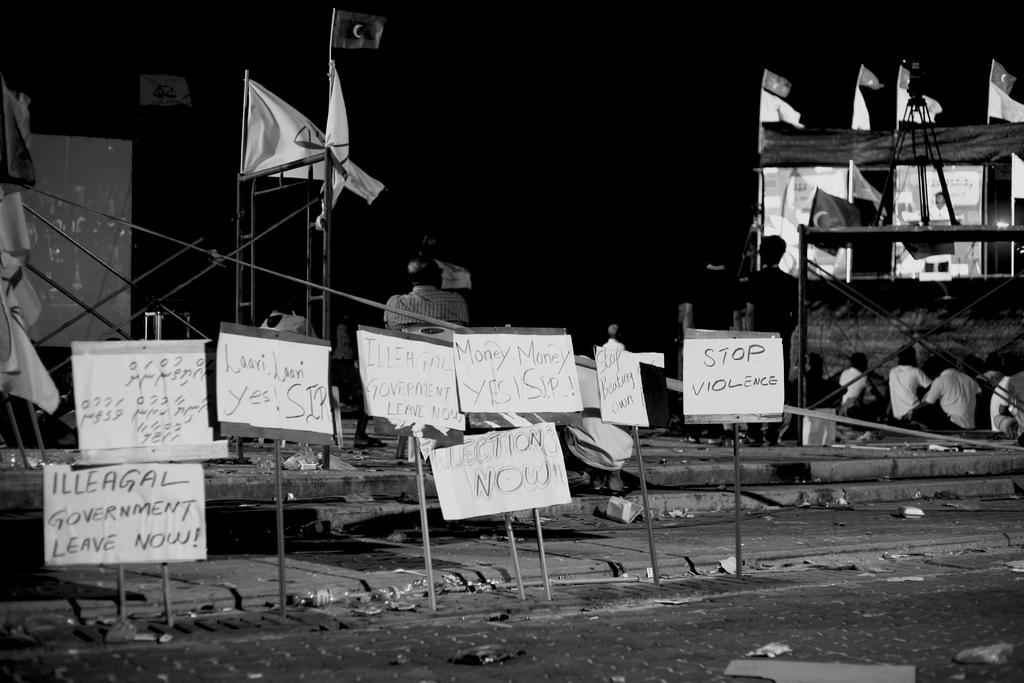What is the main subject in the center of the image? There are boards with text in the center of the image. What can be seen in the background of the image? There are flags and persons standing and sitting in the background of the image. What type of produce is being harvested by the minister in the image? There is no produce or minister present in the image. What kind of apparatus is being used by the persons in the background of the image? The provided facts do not mention any apparatus being used by the persons in the background. 